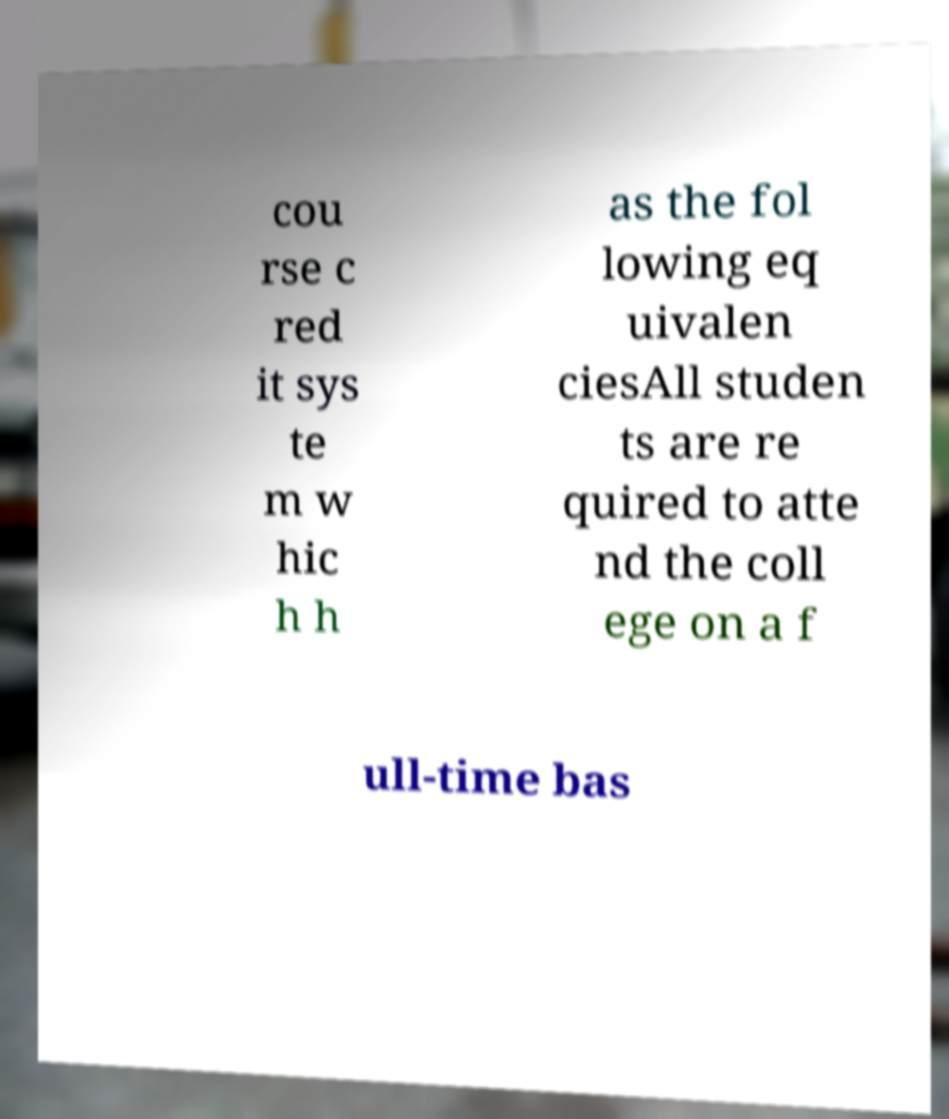There's text embedded in this image that I need extracted. Can you transcribe it verbatim? cou rse c red it sys te m w hic h h as the fol lowing eq uivalen ciesAll studen ts are re quired to atte nd the coll ege on a f ull-time bas 